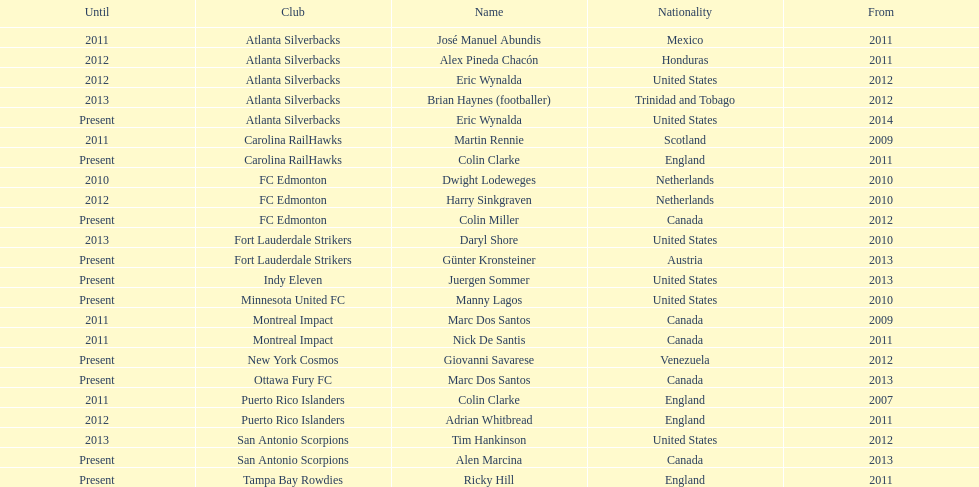How many coaches have coached from america? 6. 